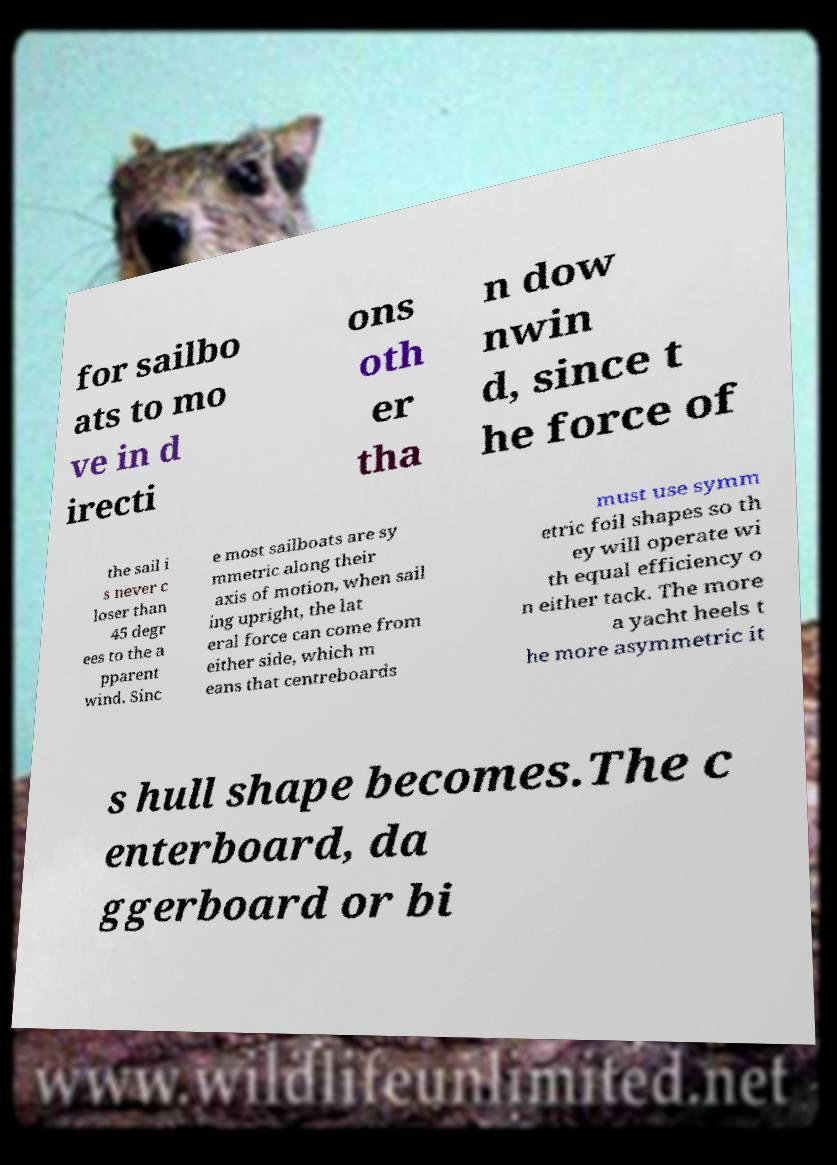Please read and relay the text visible in this image. What does it say? for sailbo ats to mo ve in d irecti ons oth er tha n dow nwin d, since t he force of the sail i s never c loser than 45 degr ees to the a pparent wind. Sinc e most sailboats are sy mmetric along their axis of motion, when sail ing upright, the lat eral force can come from either side, which m eans that centreboards must use symm etric foil shapes so th ey will operate wi th equal efficiency o n either tack. The more a yacht heels t he more asymmetric it s hull shape becomes.The c enterboard, da ggerboard or bi 